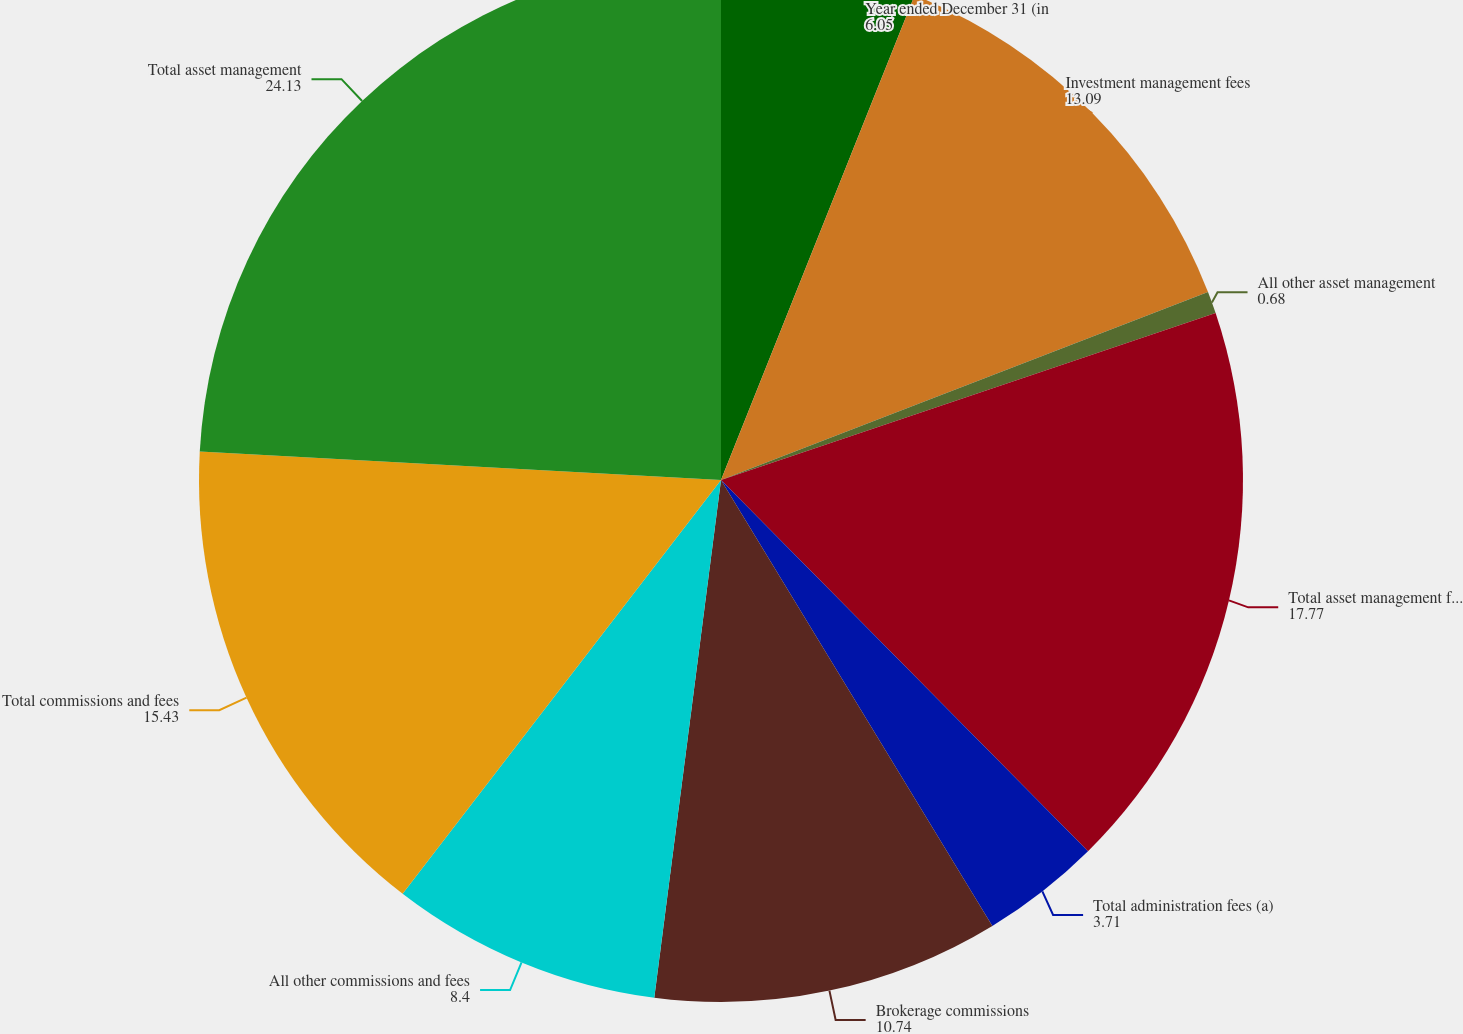Convert chart. <chart><loc_0><loc_0><loc_500><loc_500><pie_chart><fcel>Year ended December 31 (in<fcel>Investment management fees<fcel>All other asset management<fcel>Total asset management fees<fcel>Total administration fees (a)<fcel>Brokerage commissions<fcel>All other commissions and fees<fcel>Total commissions and fees<fcel>Total asset management<nl><fcel>6.05%<fcel>13.09%<fcel>0.68%<fcel>17.77%<fcel>3.71%<fcel>10.74%<fcel>8.4%<fcel>15.43%<fcel>24.13%<nl></chart> 